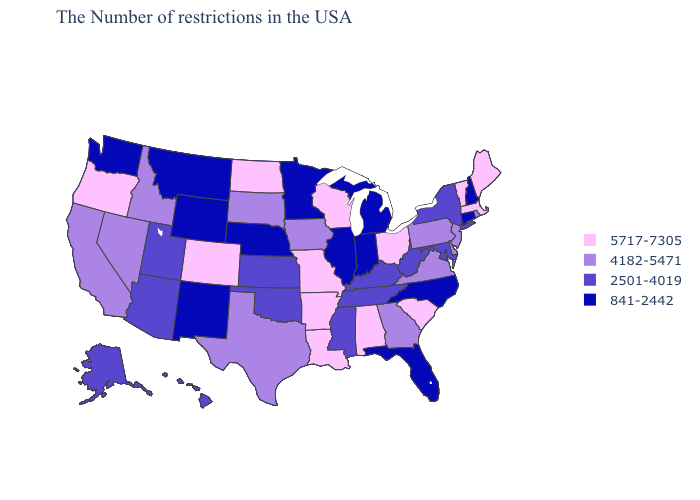What is the value of Hawaii?
Quick response, please. 2501-4019. Which states have the highest value in the USA?
Keep it brief. Maine, Massachusetts, Vermont, South Carolina, Ohio, Alabama, Wisconsin, Louisiana, Missouri, Arkansas, North Dakota, Colorado, Oregon. Name the states that have a value in the range 2501-4019?
Quick response, please. New York, Maryland, West Virginia, Kentucky, Tennessee, Mississippi, Kansas, Oklahoma, Utah, Arizona, Alaska, Hawaii. Name the states that have a value in the range 2501-4019?
Be succinct. New York, Maryland, West Virginia, Kentucky, Tennessee, Mississippi, Kansas, Oklahoma, Utah, Arizona, Alaska, Hawaii. What is the lowest value in the USA?
Give a very brief answer. 841-2442. Which states have the lowest value in the Northeast?
Be succinct. New Hampshire, Connecticut. Among the states that border Pennsylvania , does Ohio have the highest value?
Concise answer only. Yes. Does Montana have the lowest value in the West?
Be succinct. Yes. What is the value of Montana?
Quick response, please. 841-2442. Name the states that have a value in the range 2501-4019?
Short answer required. New York, Maryland, West Virginia, Kentucky, Tennessee, Mississippi, Kansas, Oklahoma, Utah, Arizona, Alaska, Hawaii. Name the states that have a value in the range 5717-7305?
Write a very short answer. Maine, Massachusetts, Vermont, South Carolina, Ohio, Alabama, Wisconsin, Louisiana, Missouri, Arkansas, North Dakota, Colorado, Oregon. Name the states that have a value in the range 5717-7305?
Answer briefly. Maine, Massachusetts, Vermont, South Carolina, Ohio, Alabama, Wisconsin, Louisiana, Missouri, Arkansas, North Dakota, Colorado, Oregon. Name the states that have a value in the range 841-2442?
Write a very short answer. New Hampshire, Connecticut, North Carolina, Florida, Michigan, Indiana, Illinois, Minnesota, Nebraska, Wyoming, New Mexico, Montana, Washington. Name the states that have a value in the range 5717-7305?
Give a very brief answer. Maine, Massachusetts, Vermont, South Carolina, Ohio, Alabama, Wisconsin, Louisiana, Missouri, Arkansas, North Dakota, Colorado, Oregon. Does the first symbol in the legend represent the smallest category?
Concise answer only. No. 